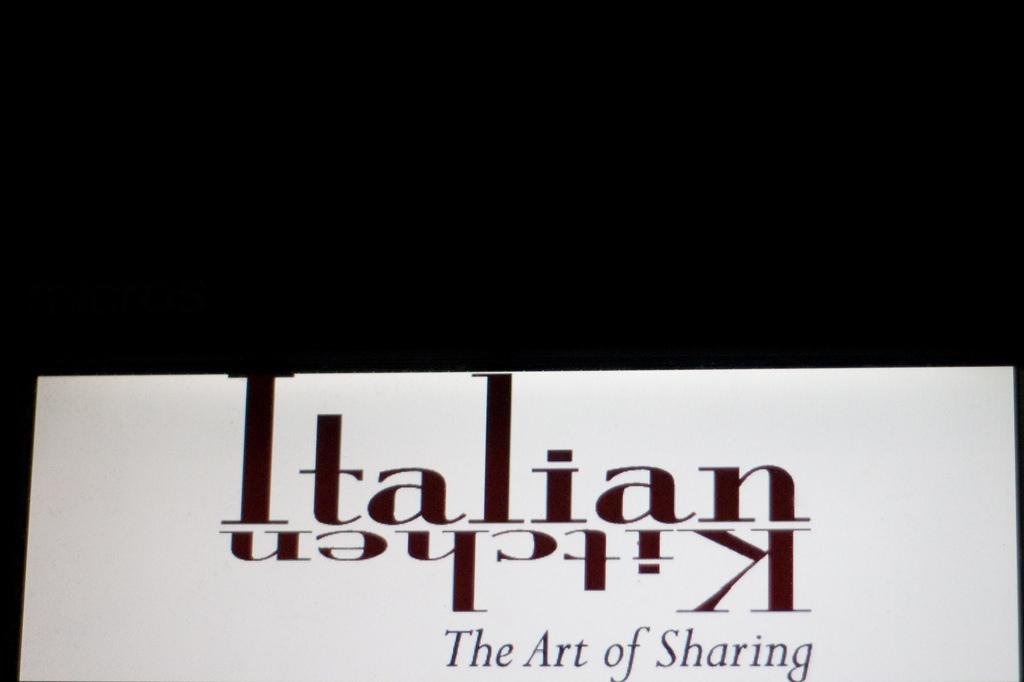<image>
Describe the image concisely. The graphic shows Italian, then Kitchen upside down. 